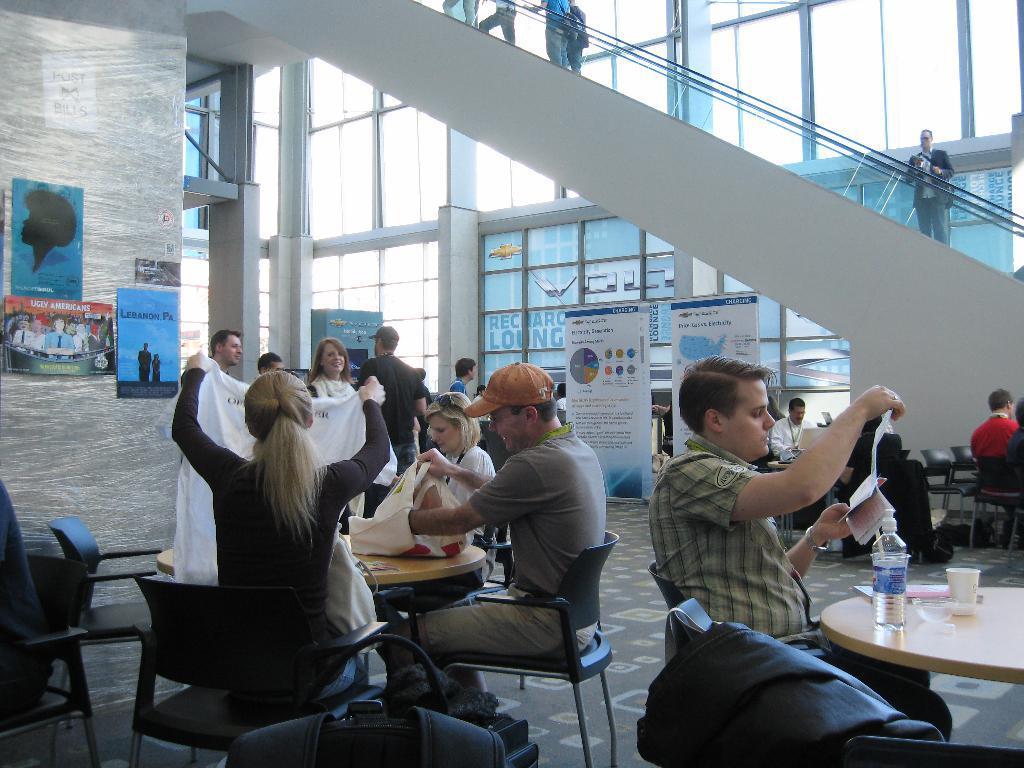How would you summarize this image in a sentence or two? In the image we can see few persons were sitting on the chair around the table. On table,we can see bag,water bottle,glass,book and tissue paper. In the bottom we can see backpack. In the background there is a wall,glass,banner,table,chairs and few persons were standing. 